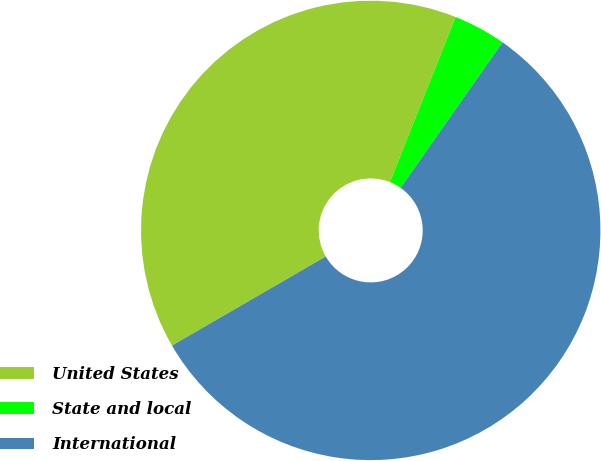Convert chart. <chart><loc_0><loc_0><loc_500><loc_500><pie_chart><fcel>United States<fcel>State and local<fcel>International<nl><fcel>39.38%<fcel>3.7%<fcel>56.91%<nl></chart> 